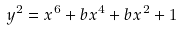<formula> <loc_0><loc_0><loc_500><loc_500>y ^ { 2 } = x ^ { 6 } + b x ^ { 4 } + b x ^ { 2 } + 1</formula> 